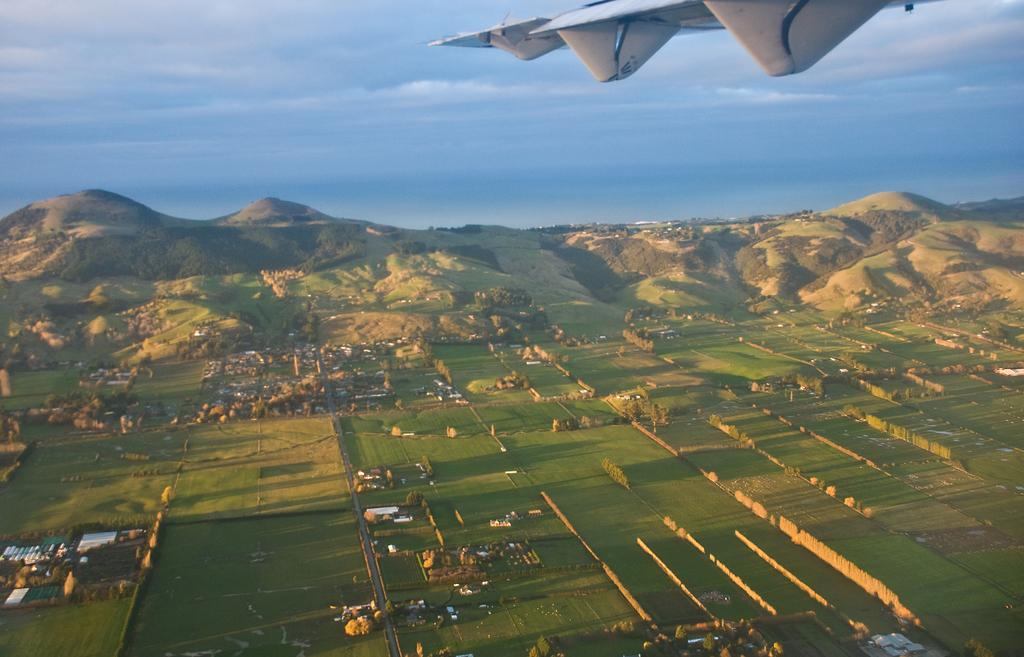What is the main subject of the image? The main subject of the image is an airplane. What type of natural features can be seen in the image? Hills, grass, trees, and the sky are visible in the image. What man-made structures are present in the image? There is a fence in the image. What is the condition of the sky in the image? The sky is visible in the image, and clouds are present. Where is the fireman putting out the fire in the bedroom in the image? There is no fireman, fire, or bedroom present in the image. The image features an airplane, hills, grass, a fence, trees, and the sky with clouds. 